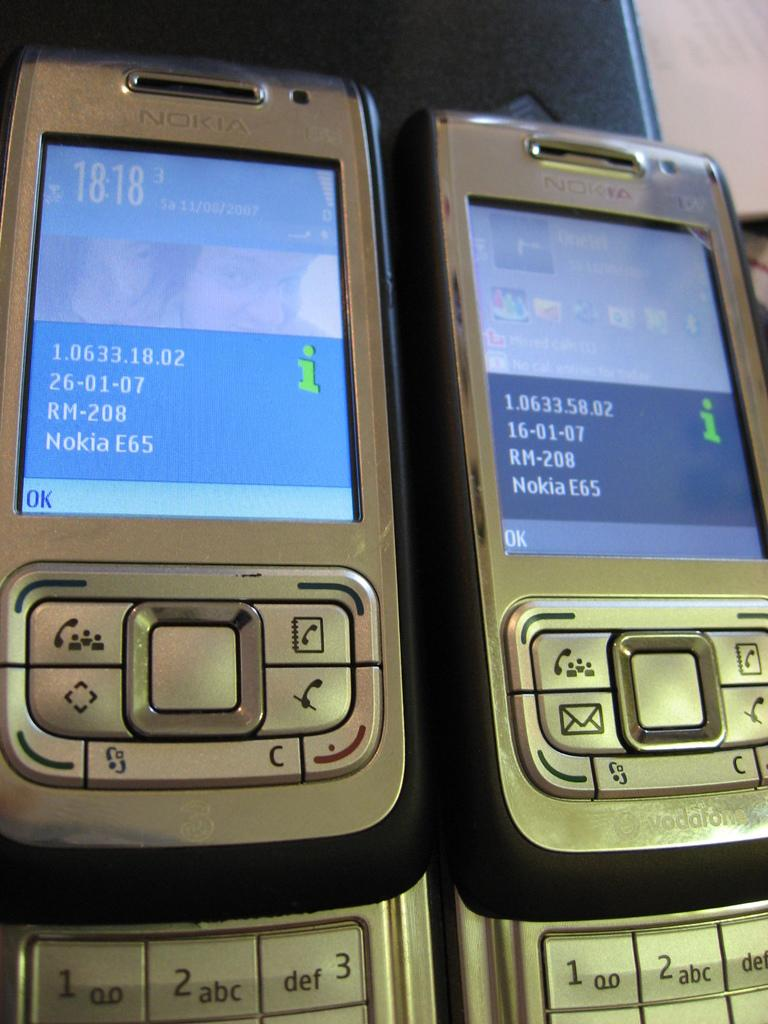<image>
Write a terse but informative summary of the picture. Two Nokia slide phones are side by side with the phone information on the screens. 